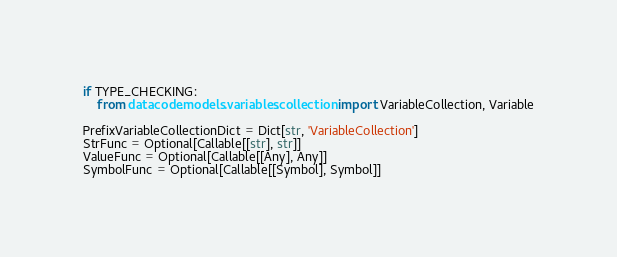<code> <loc_0><loc_0><loc_500><loc_500><_Python_>
if TYPE_CHECKING:
    from datacode.models.variables.collection import VariableCollection, Variable

PrefixVariableCollectionDict = Dict[str, 'VariableCollection']
StrFunc = Optional[Callable[[str], str]]
ValueFunc = Optional[Callable[[Any], Any]]
SymbolFunc = Optional[Callable[[Symbol], Symbol]]
</code> 